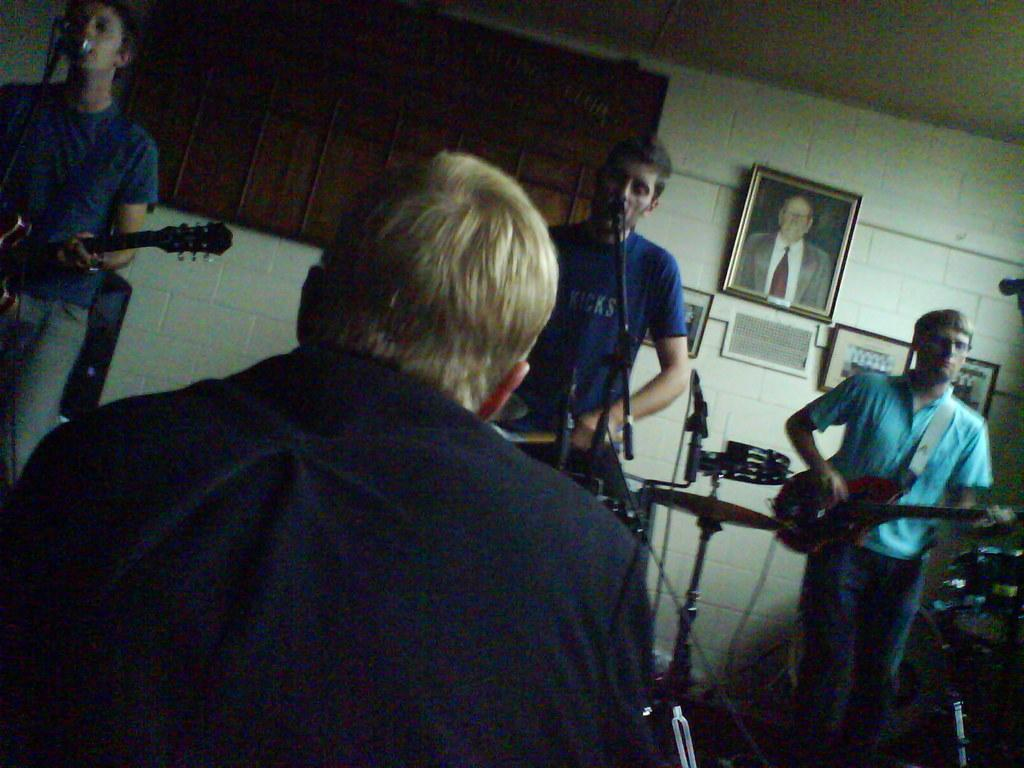How many people are present in the image? There are four people in the image. What are three of the people doing in the image? Three of the people are playing musical instruments. What is the position of the fourth person in the image? One person is seated. Can you describe any other objects or features in the image? There is a photo frame on the wall. What type of cup is being used by the person playing the guitar in the image? There is no cup present in the image, and the person playing the guitar is not using any cup. 